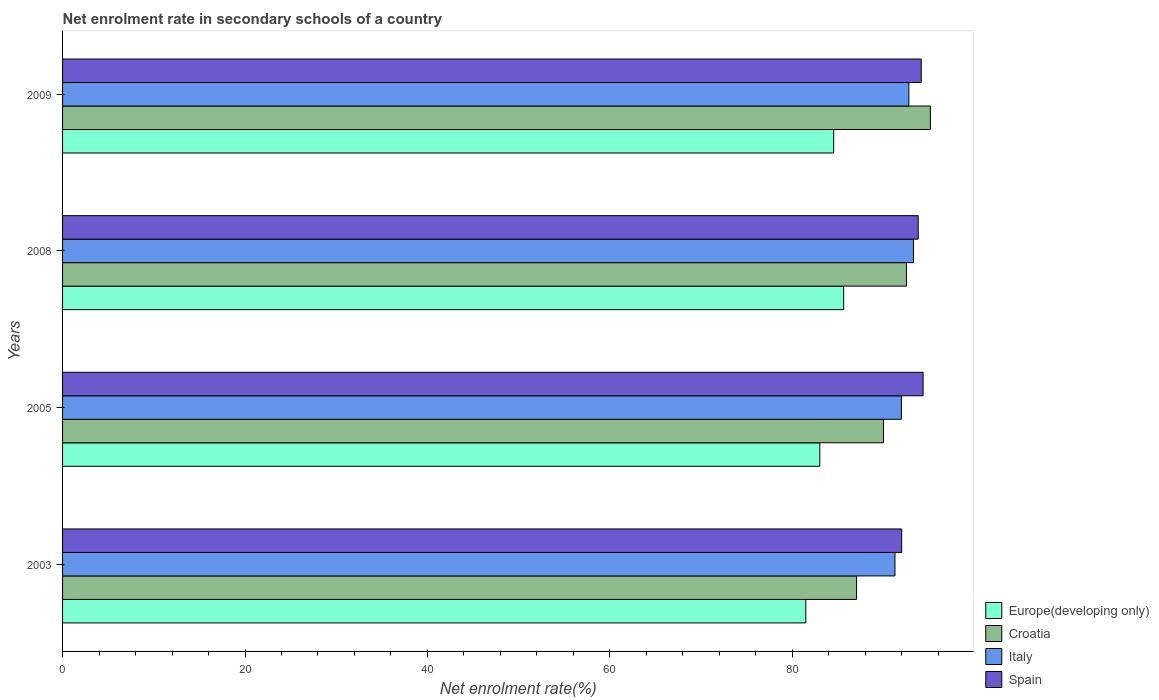How many different coloured bars are there?
Make the answer very short. 4. Are the number of bars on each tick of the Y-axis equal?
Provide a succinct answer. Yes. How many bars are there on the 3rd tick from the top?
Provide a succinct answer. 4. How many bars are there on the 1st tick from the bottom?
Provide a succinct answer. 4. What is the net enrolment rate in secondary schools in Europe(developing only) in 2009?
Offer a very short reply. 84.53. Across all years, what is the maximum net enrolment rate in secondary schools in Croatia?
Your response must be concise. 95.13. Across all years, what is the minimum net enrolment rate in secondary schools in Italy?
Provide a short and direct response. 91.25. In which year was the net enrolment rate in secondary schools in Spain maximum?
Your answer should be very brief. 2005. In which year was the net enrolment rate in secondary schools in Spain minimum?
Give a very brief answer. 2003. What is the total net enrolment rate in secondary schools in Italy in the graph?
Your answer should be compact. 369.26. What is the difference between the net enrolment rate in secondary schools in Croatia in 2008 and that in 2009?
Ensure brevity in your answer.  -2.62. What is the difference between the net enrolment rate in secondary schools in Croatia in 2005 and the net enrolment rate in secondary schools in Italy in 2009?
Provide a short and direct response. -2.79. What is the average net enrolment rate in secondary schools in Croatia per year?
Your answer should be compact. 91.17. In the year 2008, what is the difference between the net enrolment rate in secondary schools in Spain and net enrolment rate in secondary schools in Croatia?
Offer a terse response. 1.29. In how many years, is the net enrolment rate in secondary schools in Europe(developing only) greater than 76 %?
Make the answer very short. 4. What is the ratio of the net enrolment rate in secondary schools in Spain in 2008 to that in 2009?
Ensure brevity in your answer.  1. Is the net enrolment rate in secondary schools in Croatia in 2003 less than that in 2008?
Your answer should be very brief. Yes. Is the difference between the net enrolment rate in secondary schools in Spain in 2003 and 2005 greater than the difference between the net enrolment rate in secondary schools in Croatia in 2003 and 2005?
Ensure brevity in your answer.  Yes. What is the difference between the highest and the second highest net enrolment rate in secondary schools in Italy?
Ensure brevity in your answer.  0.51. What is the difference between the highest and the lowest net enrolment rate in secondary schools in Italy?
Ensure brevity in your answer.  2.03. In how many years, is the net enrolment rate in secondary schools in Spain greater than the average net enrolment rate in secondary schools in Spain taken over all years?
Keep it short and to the point. 3. Is it the case that in every year, the sum of the net enrolment rate in secondary schools in Spain and net enrolment rate in secondary schools in Europe(developing only) is greater than the sum of net enrolment rate in secondary schools in Croatia and net enrolment rate in secondary schools in Italy?
Keep it short and to the point. No. What does the 1st bar from the bottom in 2009 represents?
Ensure brevity in your answer.  Europe(developing only). Are all the bars in the graph horizontal?
Give a very brief answer. Yes. What is the difference between two consecutive major ticks on the X-axis?
Provide a short and direct response. 20. Are the values on the major ticks of X-axis written in scientific E-notation?
Keep it short and to the point. No. Does the graph contain any zero values?
Give a very brief answer. No. How many legend labels are there?
Give a very brief answer. 4. What is the title of the graph?
Offer a terse response. Net enrolment rate in secondary schools of a country. Does "Lao PDR" appear as one of the legend labels in the graph?
Provide a short and direct response. No. What is the label or title of the X-axis?
Your answer should be compact. Net enrolment rate(%). What is the label or title of the Y-axis?
Provide a succinct answer. Years. What is the Net enrolment rate(%) in Europe(developing only) in 2003?
Provide a succinct answer. 81.47. What is the Net enrolment rate(%) in Croatia in 2003?
Your answer should be very brief. 87.04. What is the Net enrolment rate(%) of Italy in 2003?
Your answer should be compact. 91.25. What is the Net enrolment rate(%) in Spain in 2003?
Keep it short and to the point. 91.99. What is the Net enrolment rate(%) in Europe(developing only) in 2005?
Ensure brevity in your answer.  83.01. What is the Net enrolment rate(%) of Croatia in 2005?
Offer a very short reply. 89.99. What is the Net enrolment rate(%) of Italy in 2005?
Give a very brief answer. 91.95. What is the Net enrolment rate(%) in Spain in 2005?
Your answer should be compact. 94.33. What is the Net enrolment rate(%) in Europe(developing only) in 2008?
Provide a short and direct response. 85.62. What is the Net enrolment rate(%) of Croatia in 2008?
Ensure brevity in your answer.  92.51. What is the Net enrolment rate(%) of Italy in 2008?
Make the answer very short. 93.28. What is the Net enrolment rate(%) of Spain in 2008?
Offer a very short reply. 93.8. What is the Net enrolment rate(%) in Europe(developing only) in 2009?
Give a very brief answer. 84.53. What is the Net enrolment rate(%) in Croatia in 2009?
Your response must be concise. 95.13. What is the Net enrolment rate(%) of Italy in 2009?
Ensure brevity in your answer.  92.78. What is the Net enrolment rate(%) of Spain in 2009?
Your answer should be compact. 94.13. Across all years, what is the maximum Net enrolment rate(%) in Europe(developing only)?
Offer a very short reply. 85.62. Across all years, what is the maximum Net enrolment rate(%) of Croatia?
Your answer should be very brief. 95.13. Across all years, what is the maximum Net enrolment rate(%) in Italy?
Your response must be concise. 93.28. Across all years, what is the maximum Net enrolment rate(%) in Spain?
Your answer should be very brief. 94.33. Across all years, what is the minimum Net enrolment rate(%) in Europe(developing only)?
Keep it short and to the point. 81.47. Across all years, what is the minimum Net enrolment rate(%) of Croatia?
Make the answer very short. 87.04. Across all years, what is the minimum Net enrolment rate(%) in Italy?
Provide a short and direct response. 91.25. Across all years, what is the minimum Net enrolment rate(%) in Spain?
Provide a succinct answer. 91.99. What is the total Net enrolment rate(%) in Europe(developing only) in the graph?
Offer a terse response. 334.64. What is the total Net enrolment rate(%) in Croatia in the graph?
Ensure brevity in your answer.  364.67. What is the total Net enrolment rate(%) of Italy in the graph?
Provide a succinct answer. 369.26. What is the total Net enrolment rate(%) in Spain in the graph?
Keep it short and to the point. 374.25. What is the difference between the Net enrolment rate(%) of Europe(developing only) in 2003 and that in 2005?
Your answer should be compact. -1.54. What is the difference between the Net enrolment rate(%) of Croatia in 2003 and that in 2005?
Your response must be concise. -2.95. What is the difference between the Net enrolment rate(%) in Italy in 2003 and that in 2005?
Offer a terse response. -0.7. What is the difference between the Net enrolment rate(%) of Spain in 2003 and that in 2005?
Give a very brief answer. -2.35. What is the difference between the Net enrolment rate(%) of Europe(developing only) in 2003 and that in 2008?
Your response must be concise. -4.15. What is the difference between the Net enrolment rate(%) in Croatia in 2003 and that in 2008?
Make the answer very short. -5.47. What is the difference between the Net enrolment rate(%) in Italy in 2003 and that in 2008?
Your answer should be very brief. -2.03. What is the difference between the Net enrolment rate(%) in Spain in 2003 and that in 2008?
Provide a short and direct response. -1.81. What is the difference between the Net enrolment rate(%) of Europe(developing only) in 2003 and that in 2009?
Your answer should be compact. -3.06. What is the difference between the Net enrolment rate(%) of Croatia in 2003 and that in 2009?
Your response must be concise. -8.09. What is the difference between the Net enrolment rate(%) of Italy in 2003 and that in 2009?
Ensure brevity in your answer.  -1.52. What is the difference between the Net enrolment rate(%) in Spain in 2003 and that in 2009?
Offer a terse response. -2.14. What is the difference between the Net enrolment rate(%) in Europe(developing only) in 2005 and that in 2008?
Offer a very short reply. -2.61. What is the difference between the Net enrolment rate(%) in Croatia in 2005 and that in 2008?
Provide a short and direct response. -2.52. What is the difference between the Net enrolment rate(%) of Italy in 2005 and that in 2008?
Your answer should be compact. -1.33. What is the difference between the Net enrolment rate(%) of Spain in 2005 and that in 2008?
Offer a very short reply. 0.54. What is the difference between the Net enrolment rate(%) of Europe(developing only) in 2005 and that in 2009?
Provide a succinct answer. -1.52. What is the difference between the Net enrolment rate(%) of Croatia in 2005 and that in 2009?
Ensure brevity in your answer.  -5.14. What is the difference between the Net enrolment rate(%) of Italy in 2005 and that in 2009?
Provide a succinct answer. -0.82. What is the difference between the Net enrolment rate(%) of Spain in 2005 and that in 2009?
Offer a terse response. 0.21. What is the difference between the Net enrolment rate(%) of Europe(developing only) in 2008 and that in 2009?
Provide a succinct answer. 1.09. What is the difference between the Net enrolment rate(%) in Croatia in 2008 and that in 2009?
Keep it short and to the point. -2.62. What is the difference between the Net enrolment rate(%) of Italy in 2008 and that in 2009?
Give a very brief answer. 0.51. What is the difference between the Net enrolment rate(%) in Spain in 2008 and that in 2009?
Offer a terse response. -0.33. What is the difference between the Net enrolment rate(%) of Europe(developing only) in 2003 and the Net enrolment rate(%) of Croatia in 2005?
Your answer should be very brief. -8.52. What is the difference between the Net enrolment rate(%) of Europe(developing only) in 2003 and the Net enrolment rate(%) of Italy in 2005?
Offer a very short reply. -10.48. What is the difference between the Net enrolment rate(%) of Europe(developing only) in 2003 and the Net enrolment rate(%) of Spain in 2005?
Provide a short and direct response. -12.86. What is the difference between the Net enrolment rate(%) in Croatia in 2003 and the Net enrolment rate(%) in Italy in 2005?
Offer a very short reply. -4.91. What is the difference between the Net enrolment rate(%) in Croatia in 2003 and the Net enrolment rate(%) in Spain in 2005?
Provide a short and direct response. -7.29. What is the difference between the Net enrolment rate(%) in Italy in 2003 and the Net enrolment rate(%) in Spain in 2005?
Your answer should be compact. -3.08. What is the difference between the Net enrolment rate(%) of Europe(developing only) in 2003 and the Net enrolment rate(%) of Croatia in 2008?
Give a very brief answer. -11.03. What is the difference between the Net enrolment rate(%) of Europe(developing only) in 2003 and the Net enrolment rate(%) of Italy in 2008?
Ensure brevity in your answer.  -11.81. What is the difference between the Net enrolment rate(%) in Europe(developing only) in 2003 and the Net enrolment rate(%) in Spain in 2008?
Make the answer very short. -12.32. What is the difference between the Net enrolment rate(%) in Croatia in 2003 and the Net enrolment rate(%) in Italy in 2008?
Give a very brief answer. -6.24. What is the difference between the Net enrolment rate(%) in Croatia in 2003 and the Net enrolment rate(%) in Spain in 2008?
Provide a short and direct response. -6.75. What is the difference between the Net enrolment rate(%) in Italy in 2003 and the Net enrolment rate(%) in Spain in 2008?
Your response must be concise. -2.55. What is the difference between the Net enrolment rate(%) of Europe(developing only) in 2003 and the Net enrolment rate(%) of Croatia in 2009?
Your answer should be compact. -13.66. What is the difference between the Net enrolment rate(%) of Europe(developing only) in 2003 and the Net enrolment rate(%) of Italy in 2009?
Give a very brief answer. -11.3. What is the difference between the Net enrolment rate(%) in Europe(developing only) in 2003 and the Net enrolment rate(%) in Spain in 2009?
Offer a terse response. -12.66. What is the difference between the Net enrolment rate(%) of Croatia in 2003 and the Net enrolment rate(%) of Italy in 2009?
Your answer should be compact. -5.73. What is the difference between the Net enrolment rate(%) of Croatia in 2003 and the Net enrolment rate(%) of Spain in 2009?
Provide a succinct answer. -7.09. What is the difference between the Net enrolment rate(%) of Italy in 2003 and the Net enrolment rate(%) of Spain in 2009?
Your answer should be very brief. -2.88. What is the difference between the Net enrolment rate(%) in Europe(developing only) in 2005 and the Net enrolment rate(%) in Croatia in 2008?
Offer a terse response. -9.5. What is the difference between the Net enrolment rate(%) in Europe(developing only) in 2005 and the Net enrolment rate(%) in Italy in 2008?
Your answer should be very brief. -10.27. What is the difference between the Net enrolment rate(%) in Europe(developing only) in 2005 and the Net enrolment rate(%) in Spain in 2008?
Your answer should be compact. -10.79. What is the difference between the Net enrolment rate(%) of Croatia in 2005 and the Net enrolment rate(%) of Italy in 2008?
Your answer should be very brief. -3.29. What is the difference between the Net enrolment rate(%) of Croatia in 2005 and the Net enrolment rate(%) of Spain in 2008?
Offer a terse response. -3.81. What is the difference between the Net enrolment rate(%) in Italy in 2005 and the Net enrolment rate(%) in Spain in 2008?
Ensure brevity in your answer.  -1.84. What is the difference between the Net enrolment rate(%) in Europe(developing only) in 2005 and the Net enrolment rate(%) in Croatia in 2009?
Provide a short and direct response. -12.12. What is the difference between the Net enrolment rate(%) of Europe(developing only) in 2005 and the Net enrolment rate(%) of Italy in 2009?
Offer a terse response. -9.76. What is the difference between the Net enrolment rate(%) in Europe(developing only) in 2005 and the Net enrolment rate(%) in Spain in 2009?
Offer a terse response. -11.12. What is the difference between the Net enrolment rate(%) of Croatia in 2005 and the Net enrolment rate(%) of Italy in 2009?
Offer a very short reply. -2.79. What is the difference between the Net enrolment rate(%) of Croatia in 2005 and the Net enrolment rate(%) of Spain in 2009?
Offer a very short reply. -4.14. What is the difference between the Net enrolment rate(%) of Italy in 2005 and the Net enrolment rate(%) of Spain in 2009?
Give a very brief answer. -2.18. What is the difference between the Net enrolment rate(%) of Europe(developing only) in 2008 and the Net enrolment rate(%) of Croatia in 2009?
Offer a very short reply. -9.51. What is the difference between the Net enrolment rate(%) in Europe(developing only) in 2008 and the Net enrolment rate(%) in Italy in 2009?
Provide a short and direct response. -7.15. What is the difference between the Net enrolment rate(%) in Europe(developing only) in 2008 and the Net enrolment rate(%) in Spain in 2009?
Ensure brevity in your answer.  -8.5. What is the difference between the Net enrolment rate(%) of Croatia in 2008 and the Net enrolment rate(%) of Italy in 2009?
Make the answer very short. -0.27. What is the difference between the Net enrolment rate(%) in Croatia in 2008 and the Net enrolment rate(%) in Spain in 2009?
Make the answer very short. -1.62. What is the difference between the Net enrolment rate(%) in Italy in 2008 and the Net enrolment rate(%) in Spain in 2009?
Ensure brevity in your answer.  -0.85. What is the average Net enrolment rate(%) in Europe(developing only) per year?
Give a very brief answer. 83.66. What is the average Net enrolment rate(%) of Croatia per year?
Provide a short and direct response. 91.17. What is the average Net enrolment rate(%) in Italy per year?
Ensure brevity in your answer.  92.32. What is the average Net enrolment rate(%) in Spain per year?
Your response must be concise. 93.56. In the year 2003, what is the difference between the Net enrolment rate(%) in Europe(developing only) and Net enrolment rate(%) in Croatia?
Provide a succinct answer. -5.57. In the year 2003, what is the difference between the Net enrolment rate(%) in Europe(developing only) and Net enrolment rate(%) in Italy?
Your answer should be very brief. -9.78. In the year 2003, what is the difference between the Net enrolment rate(%) in Europe(developing only) and Net enrolment rate(%) in Spain?
Your answer should be very brief. -10.51. In the year 2003, what is the difference between the Net enrolment rate(%) of Croatia and Net enrolment rate(%) of Italy?
Make the answer very short. -4.21. In the year 2003, what is the difference between the Net enrolment rate(%) in Croatia and Net enrolment rate(%) in Spain?
Provide a succinct answer. -4.95. In the year 2003, what is the difference between the Net enrolment rate(%) of Italy and Net enrolment rate(%) of Spain?
Make the answer very short. -0.74. In the year 2005, what is the difference between the Net enrolment rate(%) in Europe(developing only) and Net enrolment rate(%) in Croatia?
Offer a terse response. -6.98. In the year 2005, what is the difference between the Net enrolment rate(%) of Europe(developing only) and Net enrolment rate(%) of Italy?
Keep it short and to the point. -8.94. In the year 2005, what is the difference between the Net enrolment rate(%) of Europe(developing only) and Net enrolment rate(%) of Spain?
Offer a terse response. -11.32. In the year 2005, what is the difference between the Net enrolment rate(%) in Croatia and Net enrolment rate(%) in Italy?
Make the answer very short. -1.96. In the year 2005, what is the difference between the Net enrolment rate(%) of Croatia and Net enrolment rate(%) of Spain?
Offer a very short reply. -4.35. In the year 2005, what is the difference between the Net enrolment rate(%) of Italy and Net enrolment rate(%) of Spain?
Ensure brevity in your answer.  -2.38. In the year 2008, what is the difference between the Net enrolment rate(%) of Europe(developing only) and Net enrolment rate(%) of Croatia?
Your response must be concise. -6.88. In the year 2008, what is the difference between the Net enrolment rate(%) of Europe(developing only) and Net enrolment rate(%) of Italy?
Your answer should be very brief. -7.66. In the year 2008, what is the difference between the Net enrolment rate(%) in Europe(developing only) and Net enrolment rate(%) in Spain?
Your answer should be compact. -8.17. In the year 2008, what is the difference between the Net enrolment rate(%) in Croatia and Net enrolment rate(%) in Italy?
Offer a terse response. -0.77. In the year 2008, what is the difference between the Net enrolment rate(%) of Croatia and Net enrolment rate(%) of Spain?
Provide a succinct answer. -1.29. In the year 2008, what is the difference between the Net enrolment rate(%) of Italy and Net enrolment rate(%) of Spain?
Your response must be concise. -0.51. In the year 2009, what is the difference between the Net enrolment rate(%) of Europe(developing only) and Net enrolment rate(%) of Croatia?
Make the answer very short. -10.6. In the year 2009, what is the difference between the Net enrolment rate(%) of Europe(developing only) and Net enrolment rate(%) of Italy?
Your answer should be compact. -8.24. In the year 2009, what is the difference between the Net enrolment rate(%) of Europe(developing only) and Net enrolment rate(%) of Spain?
Provide a short and direct response. -9.6. In the year 2009, what is the difference between the Net enrolment rate(%) of Croatia and Net enrolment rate(%) of Italy?
Give a very brief answer. 2.36. In the year 2009, what is the difference between the Net enrolment rate(%) in Italy and Net enrolment rate(%) in Spain?
Provide a short and direct response. -1.35. What is the ratio of the Net enrolment rate(%) of Europe(developing only) in 2003 to that in 2005?
Provide a short and direct response. 0.98. What is the ratio of the Net enrolment rate(%) in Croatia in 2003 to that in 2005?
Keep it short and to the point. 0.97. What is the ratio of the Net enrolment rate(%) in Spain in 2003 to that in 2005?
Give a very brief answer. 0.98. What is the ratio of the Net enrolment rate(%) of Europe(developing only) in 2003 to that in 2008?
Your answer should be very brief. 0.95. What is the ratio of the Net enrolment rate(%) of Croatia in 2003 to that in 2008?
Provide a short and direct response. 0.94. What is the ratio of the Net enrolment rate(%) in Italy in 2003 to that in 2008?
Offer a terse response. 0.98. What is the ratio of the Net enrolment rate(%) of Spain in 2003 to that in 2008?
Keep it short and to the point. 0.98. What is the ratio of the Net enrolment rate(%) in Europe(developing only) in 2003 to that in 2009?
Provide a succinct answer. 0.96. What is the ratio of the Net enrolment rate(%) in Croatia in 2003 to that in 2009?
Give a very brief answer. 0.92. What is the ratio of the Net enrolment rate(%) of Italy in 2003 to that in 2009?
Provide a succinct answer. 0.98. What is the ratio of the Net enrolment rate(%) in Spain in 2003 to that in 2009?
Ensure brevity in your answer.  0.98. What is the ratio of the Net enrolment rate(%) of Europe(developing only) in 2005 to that in 2008?
Your response must be concise. 0.97. What is the ratio of the Net enrolment rate(%) of Croatia in 2005 to that in 2008?
Give a very brief answer. 0.97. What is the ratio of the Net enrolment rate(%) of Italy in 2005 to that in 2008?
Provide a succinct answer. 0.99. What is the ratio of the Net enrolment rate(%) of Croatia in 2005 to that in 2009?
Offer a very short reply. 0.95. What is the ratio of the Net enrolment rate(%) in Italy in 2005 to that in 2009?
Your answer should be compact. 0.99. What is the ratio of the Net enrolment rate(%) of Europe(developing only) in 2008 to that in 2009?
Your response must be concise. 1.01. What is the ratio of the Net enrolment rate(%) in Croatia in 2008 to that in 2009?
Provide a short and direct response. 0.97. What is the ratio of the Net enrolment rate(%) of Italy in 2008 to that in 2009?
Your answer should be compact. 1.01. What is the ratio of the Net enrolment rate(%) in Spain in 2008 to that in 2009?
Give a very brief answer. 1. What is the difference between the highest and the second highest Net enrolment rate(%) in Europe(developing only)?
Provide a short and direct response. 1.09. What is the difference between the highest and the second highest Net enrolment rate(%) in Croatia?
Ensure brevity in your answer.  2.62. What is the difference between the highest and the second highest Net enrolment rate(%) in Italy?
Your answer should be compact. 0.51. What is the difference between the highest and the second highest Net enrolment rate(%) of Spain?
Provide a short and direct response. 0.21. What is the difference between the highest and the lowest Net enrolment rate(%) in Europe(developing only)?
Provide a succinct answer. 4.15. What is the difference between the highest and the lowest Net enrolment rate(%) of Croatia?
Give a very brief answer. 8.09. What is the difference between the highest and the lowest Net enrolment rate(%) of Italy?
Offer a terse response. 2.03. What is the difference between the highest and the lowest Net enrolment rate(%) of Spain?
Your answer should be very brief. 2.35. 